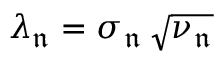<formula> <loc_0><loc_0><loc_500><loc_500>\lambda _ { \mathfrak { n } } = \sigma _ { \mathfrak { n } } \, \sqrt { \nu _ { \mathfrak { n } } }</formula> 